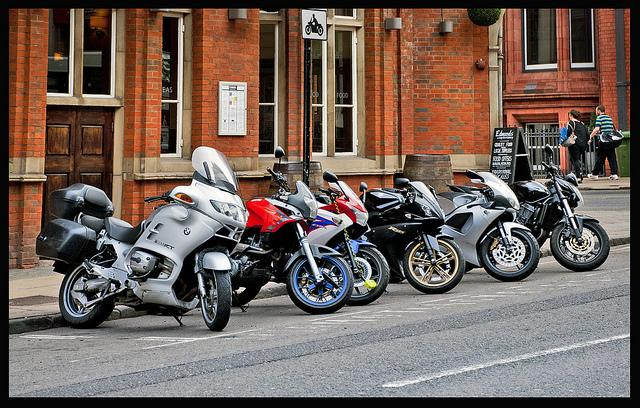What are bricks mostly made of? clay 